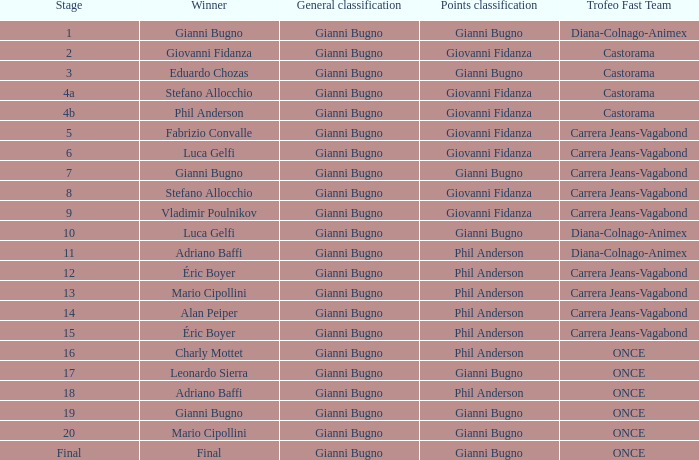Which team holds the fastest record in stage 10 of the trofeo? Diana-Colnago-Animex. 